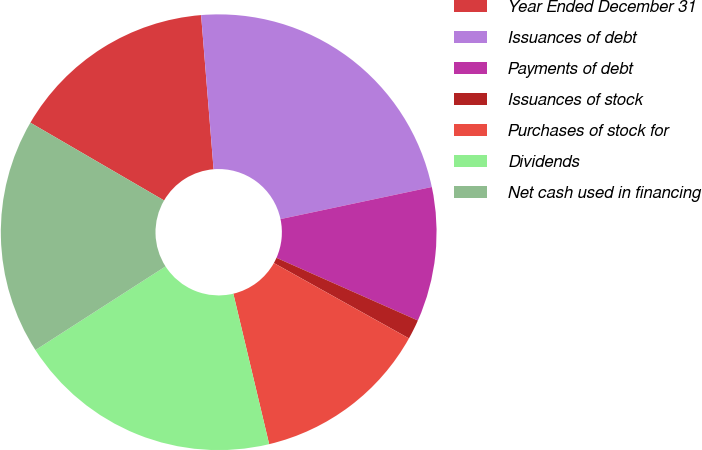Convert chart. <chart><loc_0><loc_0><loc_500><loc_500><pie_chart><fcel>Year Ended December 31<fcel>Issuances of debt<fcel>Payments of debt<fcel>Issuances of stock<fcel>Purchases of stock for<fcel>Dividends<fcel>Net cash used in financing<nl><fcel>15.33%<fcel>22.96%<fcel>9.97%<fcel>1.46%<fcel>13.18%<fcel>19.63%<fcel>17.48%<nl></chart> 